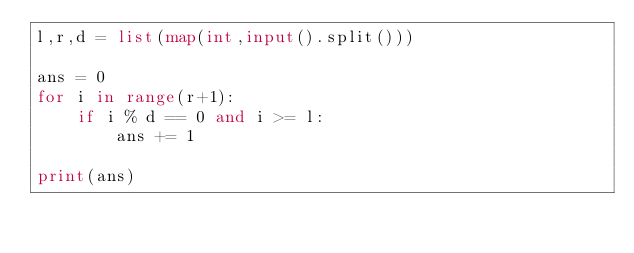<code> <loc_0><loc_0><loc_500><loc_500><_Python_>l,r,d = list(map(int,input().split()))

ans = 0
for i in range(r+1):
    if i % d == 0 and i >= l:
        ans += 1

print(ans)</code> 